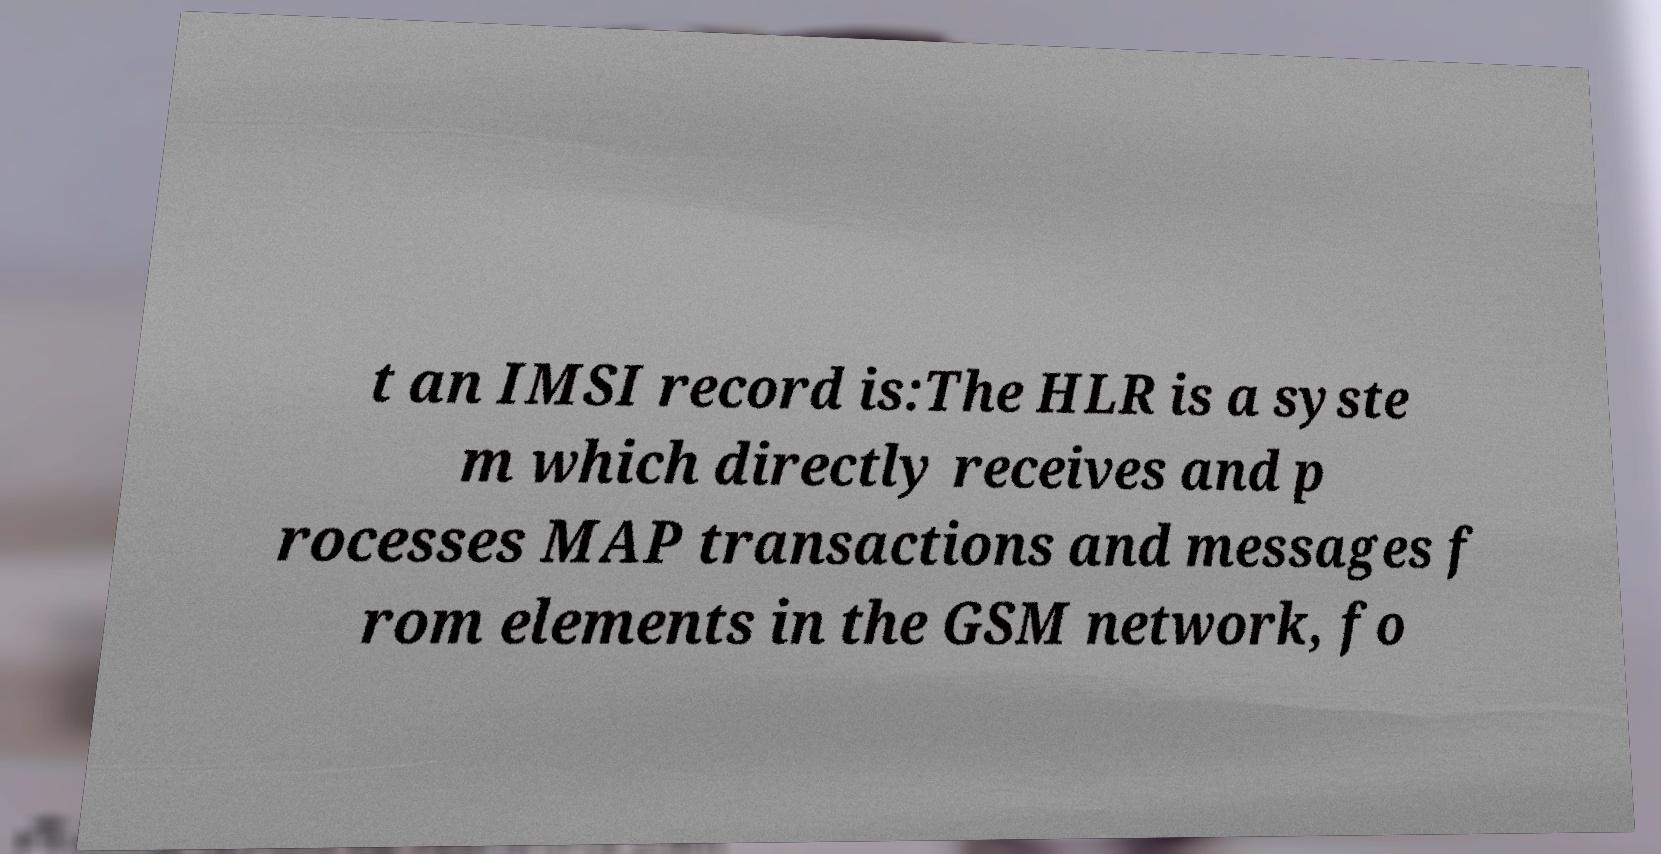I need the written content from this picture converted into text. Can you do that? t an IMSI record is:The HLR is a syste m which directly receives and p rocesses MAP transactions and messages f rom elements in the GSM network, fo 